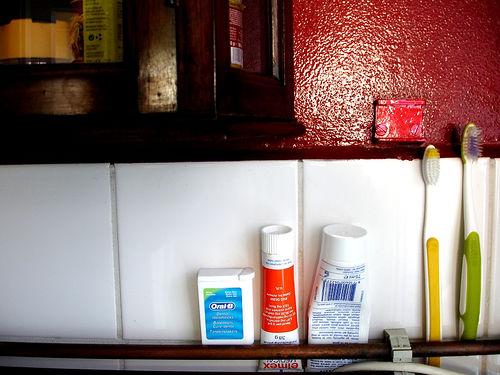What brand is the dental floss?
Be succinct. Oral b. Is there soap visible?
Be succinct. No. How many toothbrushes are there?
Give a very brief answer. 2. 